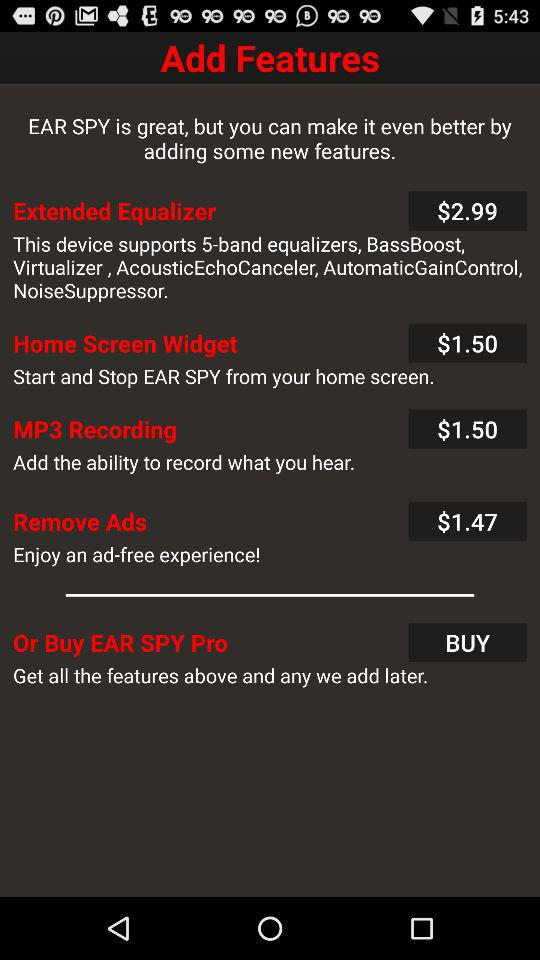How many features are available for purchase?
Answer the question using a single word or phrase. 5 